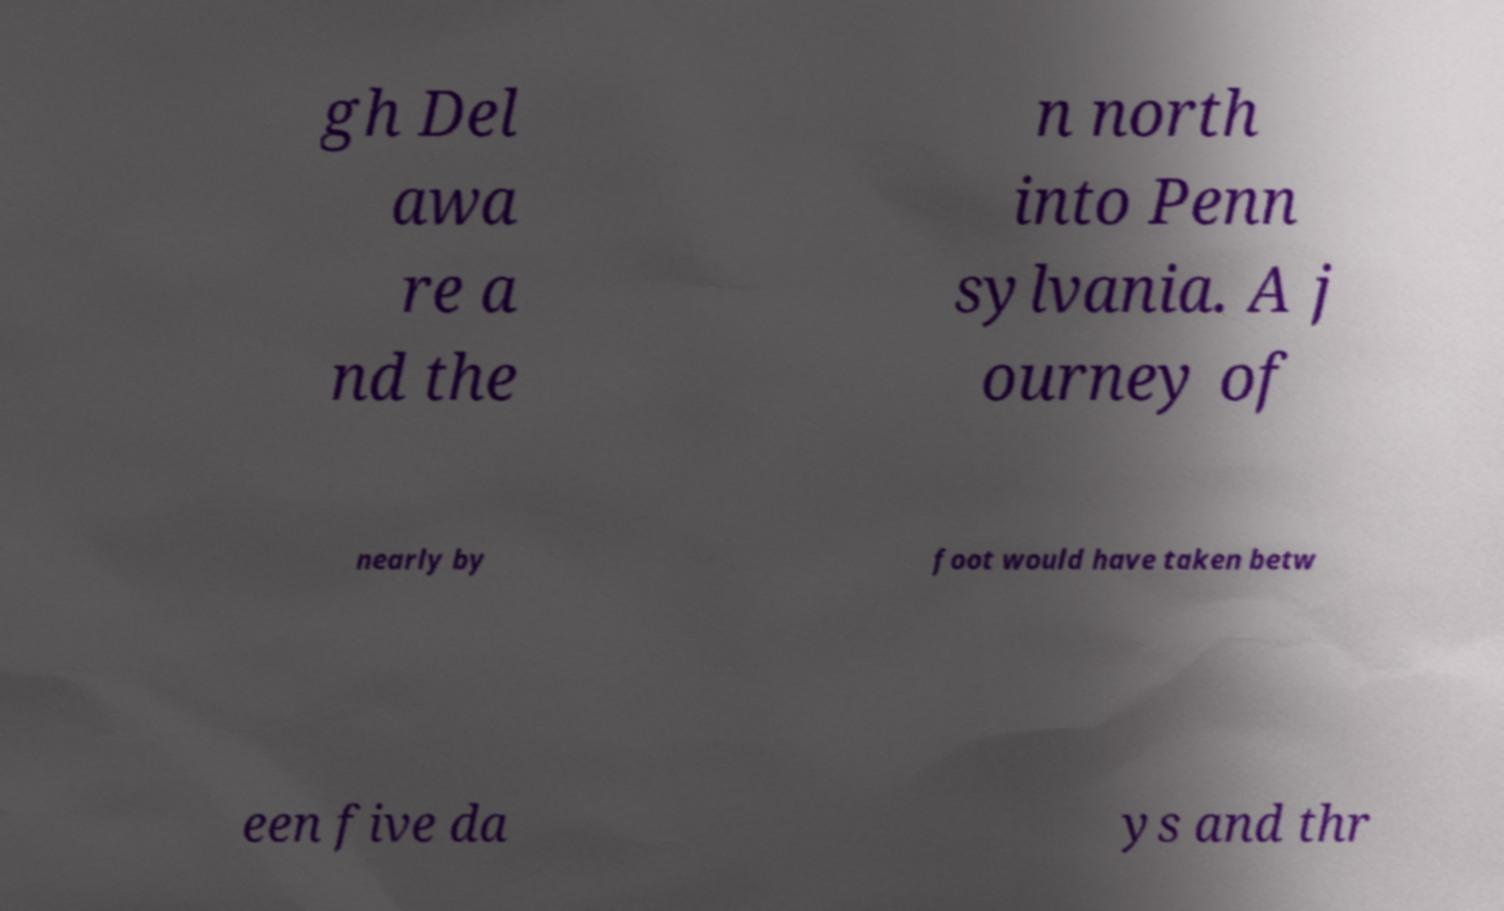For documentation purposes, I need the text within this image transcribed. Could you provide that? gh Del awa re a nd the n north into Penn sylvania. A j ourney of nearly by foot would have taken betw een five da ys and thr 